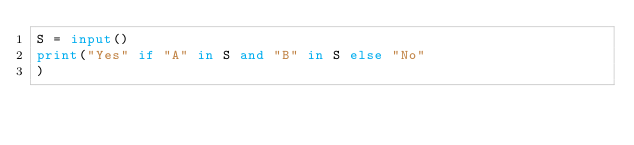Convert code to text. <code><loc_0><loc_0><loc_500><loc_500><_Python_>S = input()
print("Yes" if "A" in S and "B" in S else "No"
)</code> 